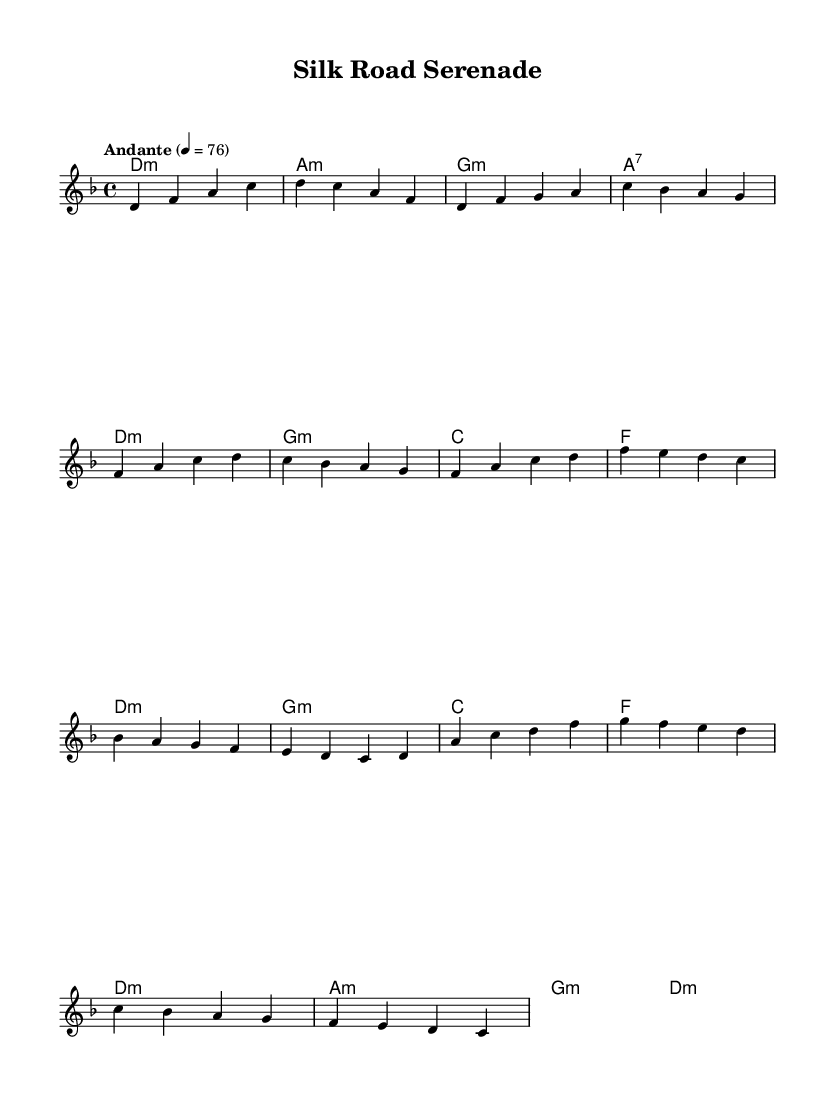What is the key signature of this music? The key signature is D minor, which has one flat (B flat). It indicates that the melody will primarily use notes from the D natural minor scale.
Answer: D minor What is the time signature of the piece? The time signature is 4/4, which means there are four beats in each measure, and each quarter note gets one beat. This is a common time signature that provides a steady rhythm suitable for ballads.
Answer: 4/4 What is the tempo marking indicated? The tempo marking is "Andante," which suggests a moderate pace, typically around 76 beats per minute. It sets a relaxed and flowing character for the piece, appropriate for a serenade.
Answer: Andante List the chord used in the introduction. The chords used in the introduction are D minor, A minor, G minor, and A seventh. This progression sets the tonal foundation for the piece.
Answer: D minor, A minor, G minor, A seventh In which section does the bridge start? The bridge starts after the chorus, which is structured after the initial verses. It introduces new melodic and harmonic content, creating contrast within the piece. The bridge allows for exploration and development.
Answer: Bridge How many measures are present in the chorus? The chorus has four measures as indicated by the grouping of notes and chord changes. This section is typically designed to be memorable and forms the thematic core of the piece.
Answer: 4 What type of music fusion does this piece represent? This piece represents a fusion of Indian classical music and Western pop elements. The use of scales, rhythms, and melodic ornamentation from Indian classical music is typically blended with the harmonic structure and instrumentation of Western pop.
Answer: Fusion of Indian classical and Western pop 